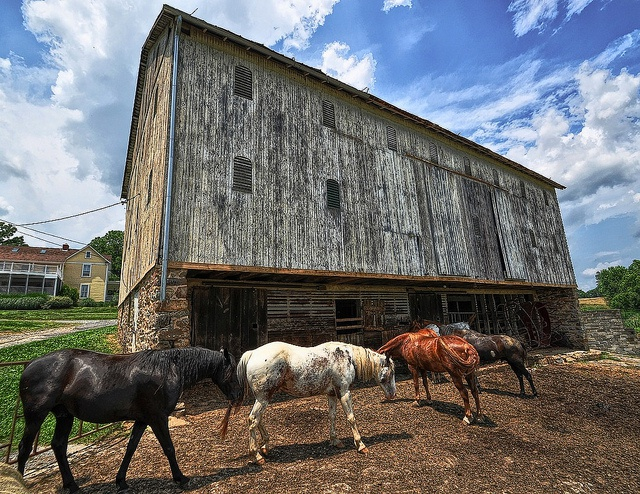Describe the objects in this image and their specific colors. I can see horse in gray, black, and darkgreen tones, horse in gray, black, ivory, and maroon tones, horse in gray, black, maroon, and brown tones, and horse in gray, black, and maroon tones in this image. 